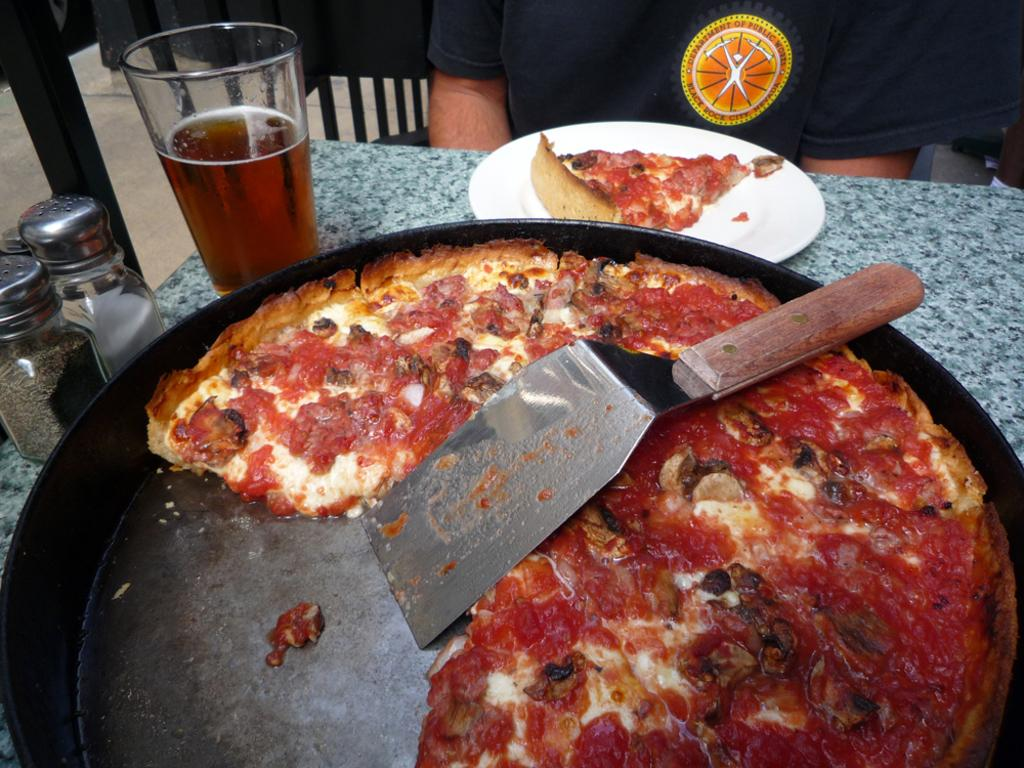What type of food is in the pan in the image? There is a pizza in the pan in the image. What type of glassware is visible in the image? There is a wine glass in the image. Where are the glass jars located in the image? The glass jars are on the left side of the image. What type of fuel is being used to power the pizza in the image? There is no fuel present in the image, as the pizza is not a machine or device that requires fuel to operate. 